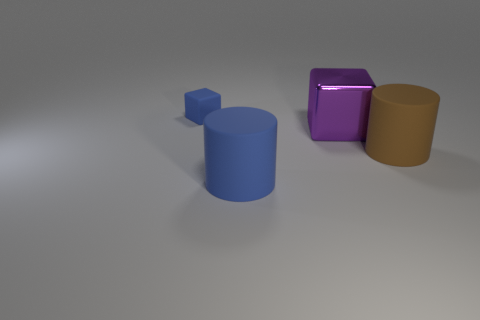Add 4 large brown things. How many objects exist? 8 Add 4 large gray matte cylinders. How many large gray matte cylinders exist? 4 Subtract 0 purple balls. How many objects are left? 4 Subtract all small green cubes. Subtract all rubber cylinders. How many objects are left? 2 Add 3 large brown things. How many large brown things are left? 4 